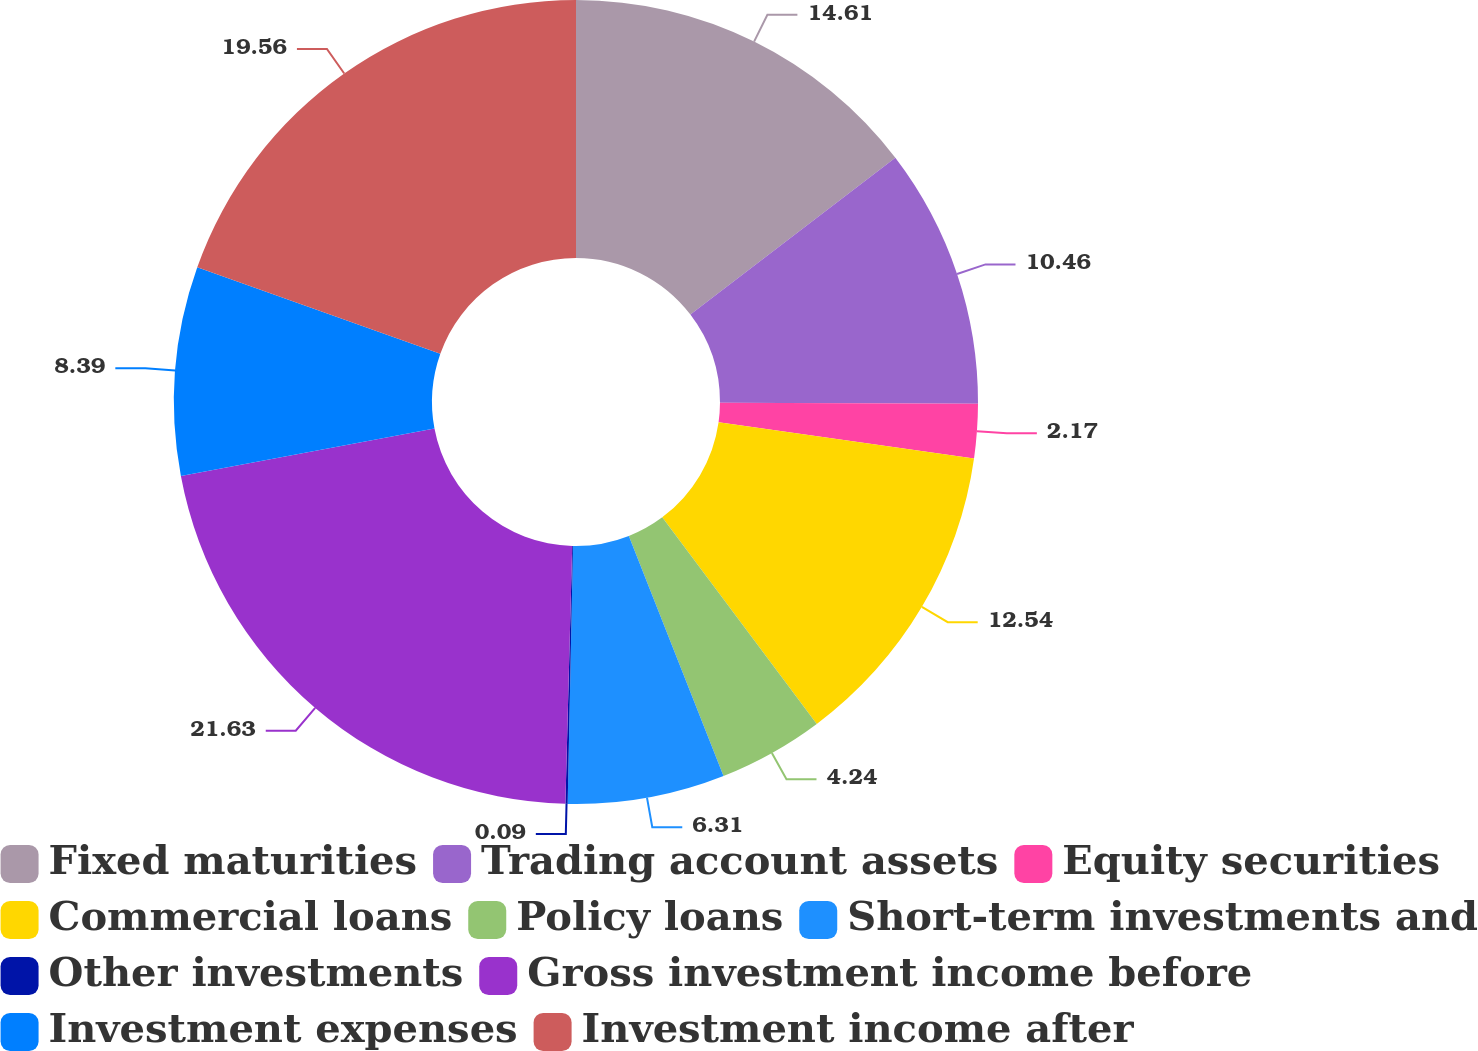Convert chart to OTSL. <chart><loc_0><loc_0><loc_500><loc_500><pie_chart><fcel>Fixed maturities<fcel>Trading account assets<fcel>Equity securities<fcel>Commercial loans<fcel>Policy loans<fcel>Short-term investments and<fcel>Other investments<fcel>Gross investment income before<fcel>Investment expenses<fcel>Investment income after<nl><fcel>14.61%<fcel>10.46%<fcel>2.17%<fcel>12.54%<fcel>4.24%<fcel>6.31%<fcel>0.09%<fcel>21.63%<fcel>8.39%<fcel>19.56%<nl></chart> 